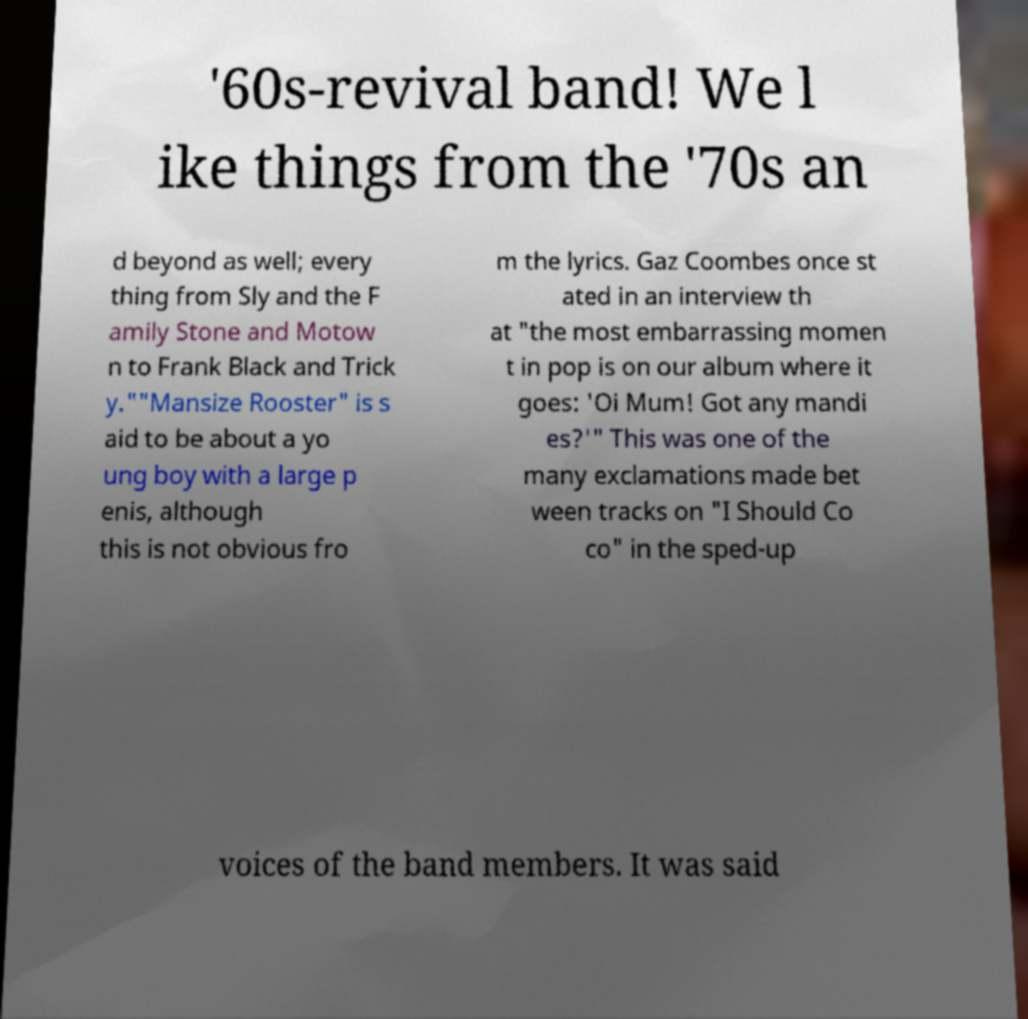Can you accurately transcribe the text from the provided image for me? '60s-revival band! We l ike things from the '70s an d beyond as well; every thing from Sly and the F amily Stone and Motow n to Frank Black and Trick y.""Mansize Rooster" is s aid to be about a yo ung boy with a large p enis, although this is not obvious fro m the lyrics. Gaz Coombes once st ated in an interview th at "the most embarrassing momen t in pop is on our album where it goes: 'Oi Mum! Got any mandi es?'" This was one of the many exclamations made bet ween tracks on "I Should Co co" in the sped-up voices of the band members. It was said 